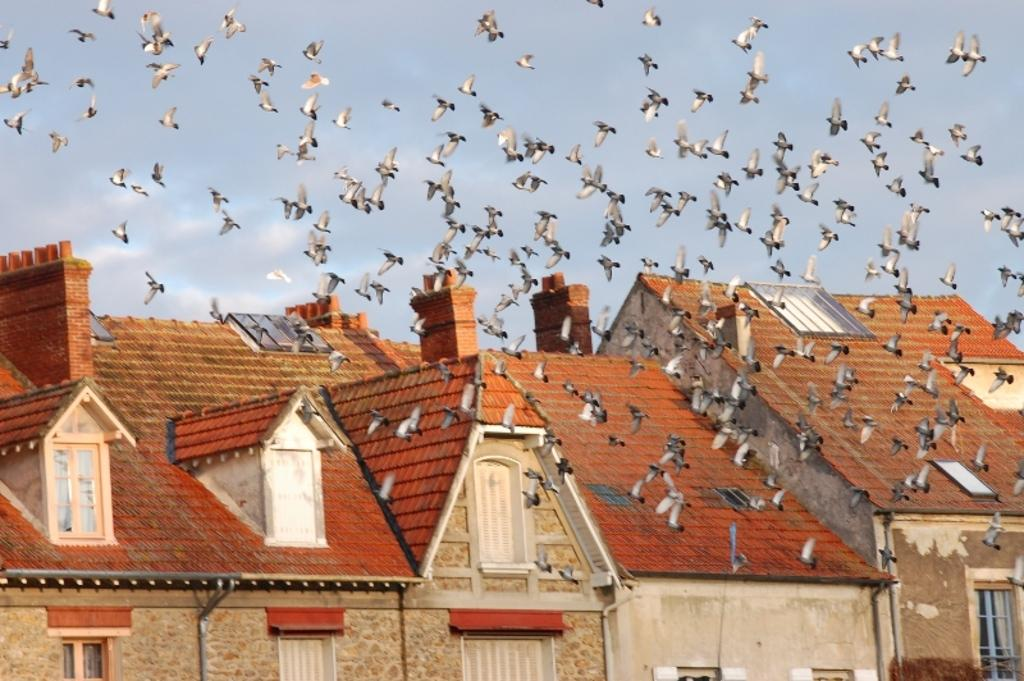What type of structures can be seen in the image? There are houses in the image. What animals are present in the image? There are birds in the image. What part of the natural environment is visible in the image? The sky is visible in the image. What type of cow can be seen grazing in the image? There is no cow present in the image; it features houses and birds. 